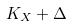<formula> <loc_0><loc_0><loc_500><loc_500>K _ { X } + \Delta</formula> 